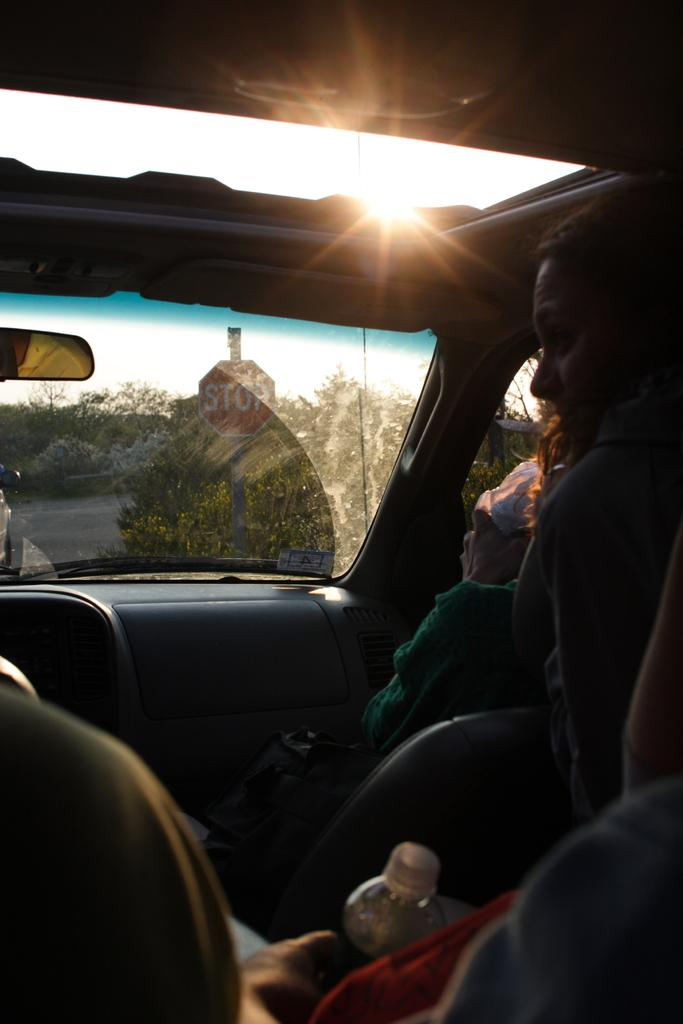Where was the image taken? The image was taken inside a car. Who is present in the car? There are people sitting in the car. What object is one person holding? One person is holding a water bottle. What can be seen through the glass of the car? A stop board and plants are visible through the glass. What type of linen is draped over the seats in the image? There is no linen draped over the seats in the image; it is a car interior with people and objects visible. 